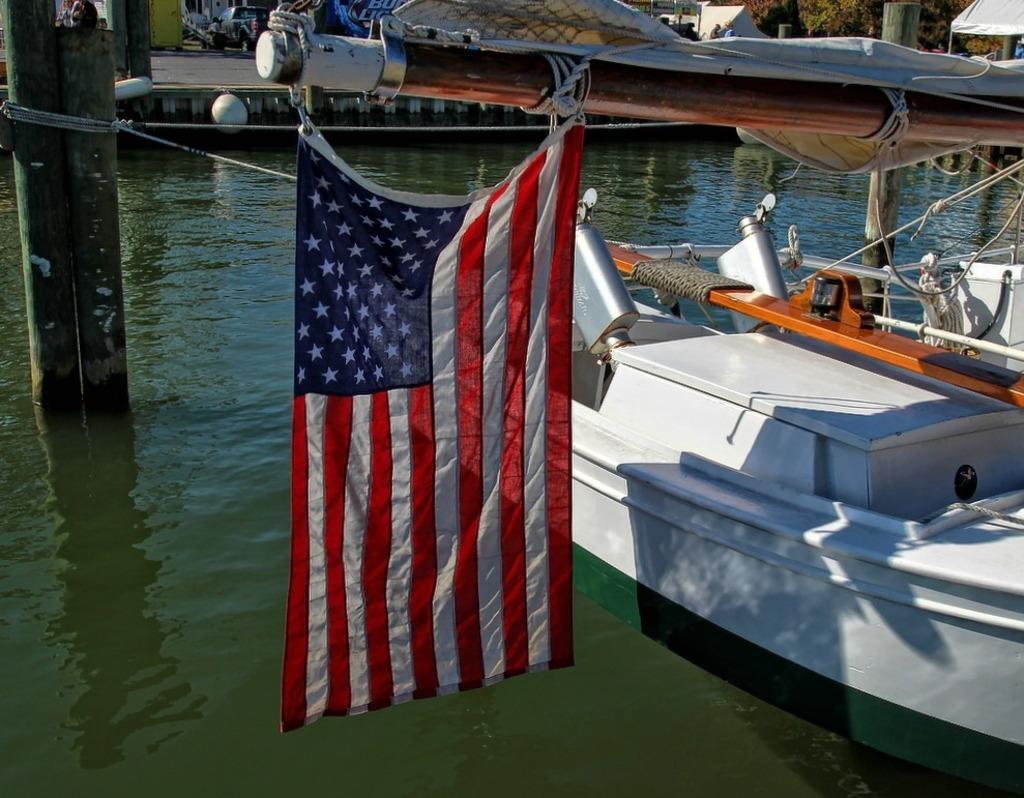Describe this image in one or two sentences. In the picture I can see a flag is hanged to the pole, I can see a a white color boat is floating on the water, I can see the pillars, a vehicle and trees in the background. 